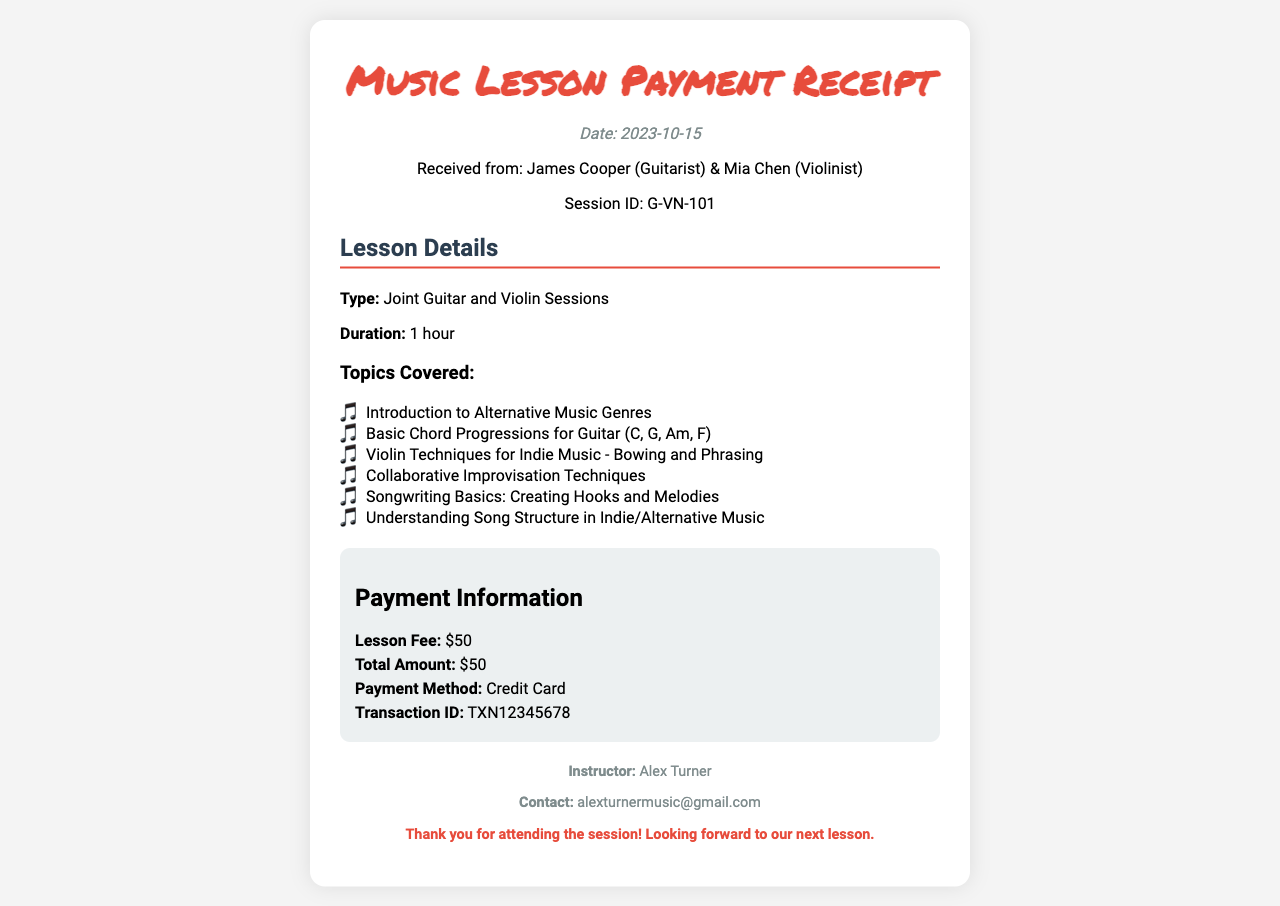What is the date of the lesson? The date of the lesson is specifically mentioned in the receipt.
Answer: 2023-10-15 Who are the participants in the session? The receipt lists the names of the individuals participating in the music lesson.
Answer: James Cooper (Guitarist) & Mia Chen (Violinist) What is the duration of the session? The document states the length of the lesson in hours.
Answer: 1 hour What was the lesson fee? The exact fee for the music lesson is provided in the payment information section of the receipt.
Answer: $50 What is one of the topics covered in the lesson? The topics section lists various subjects discussed during the session.
Answer: Introduction to Alternative Music Genres What is the payment method used? The payment information section specifies the method of payment for the lesson.
Answer: Credit Card What is the transaction ID? The receipt includes a unique identifier for the payment transaction.
Answer: TXN12345678 Who is the instructor for the session? The footer of the document identifies the person teaching the lesson.
Answer: Alex Turner What is included in the pricing section? The pricing section contains details about the fees and transaction specifics for the lesson.
Answer: Lesson Fee, Total Amount, Payment Method, Transaction ID 